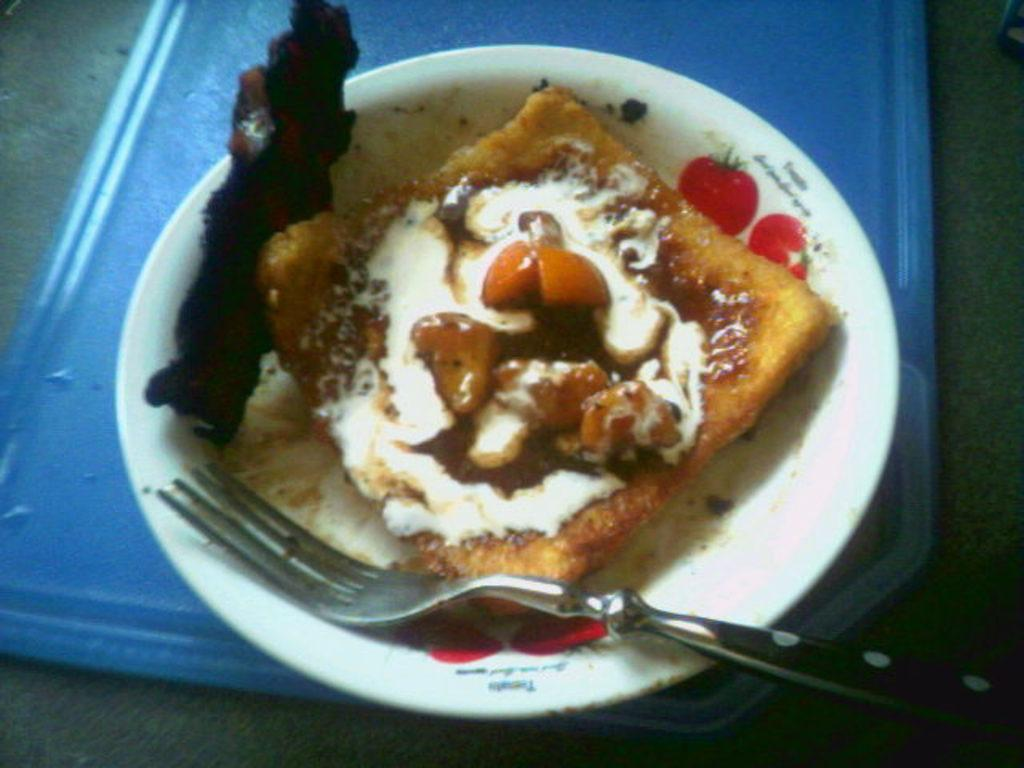What is located in the center of the image? There is a tray in the center of the image. What is on the tray? The tray contains a plate. What is on the plate? The plate has dessert on it. What utensil is present on the plate? There is a fork on the plate. What can be seen in the background of the image? The background of the image includes the floor. How many kittens are playing with the mint on the truck in the image? There are no kittens, mint, or truck present in the image. 